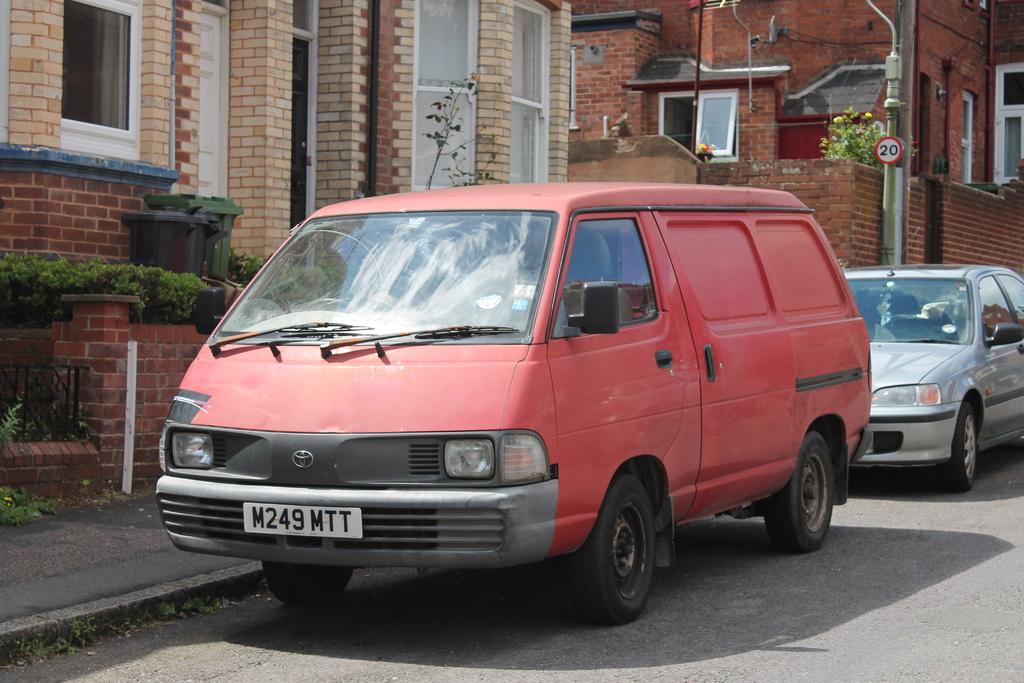What is the license plate of the red van?
Your response must be concise. M249mtt. What number is on the pole?
Provide a succinct answer. 20. 